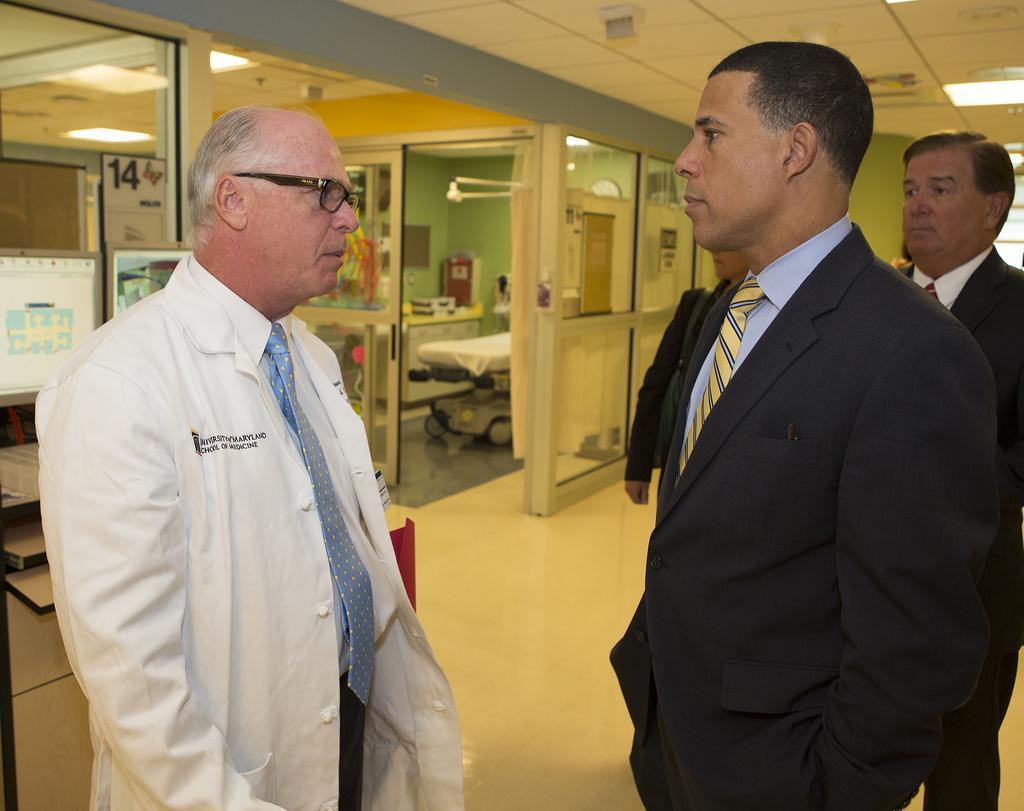In one or two sentences, can you explain what this image depicts? This picture is taken inside the room. In this image, on the right side and left side, we can see two men are standing on the floor. On the right side, we can see another man standing. In the background, we can see a table, staircase, keyboard, monitor. At the top, we can see a roof with few lights. 